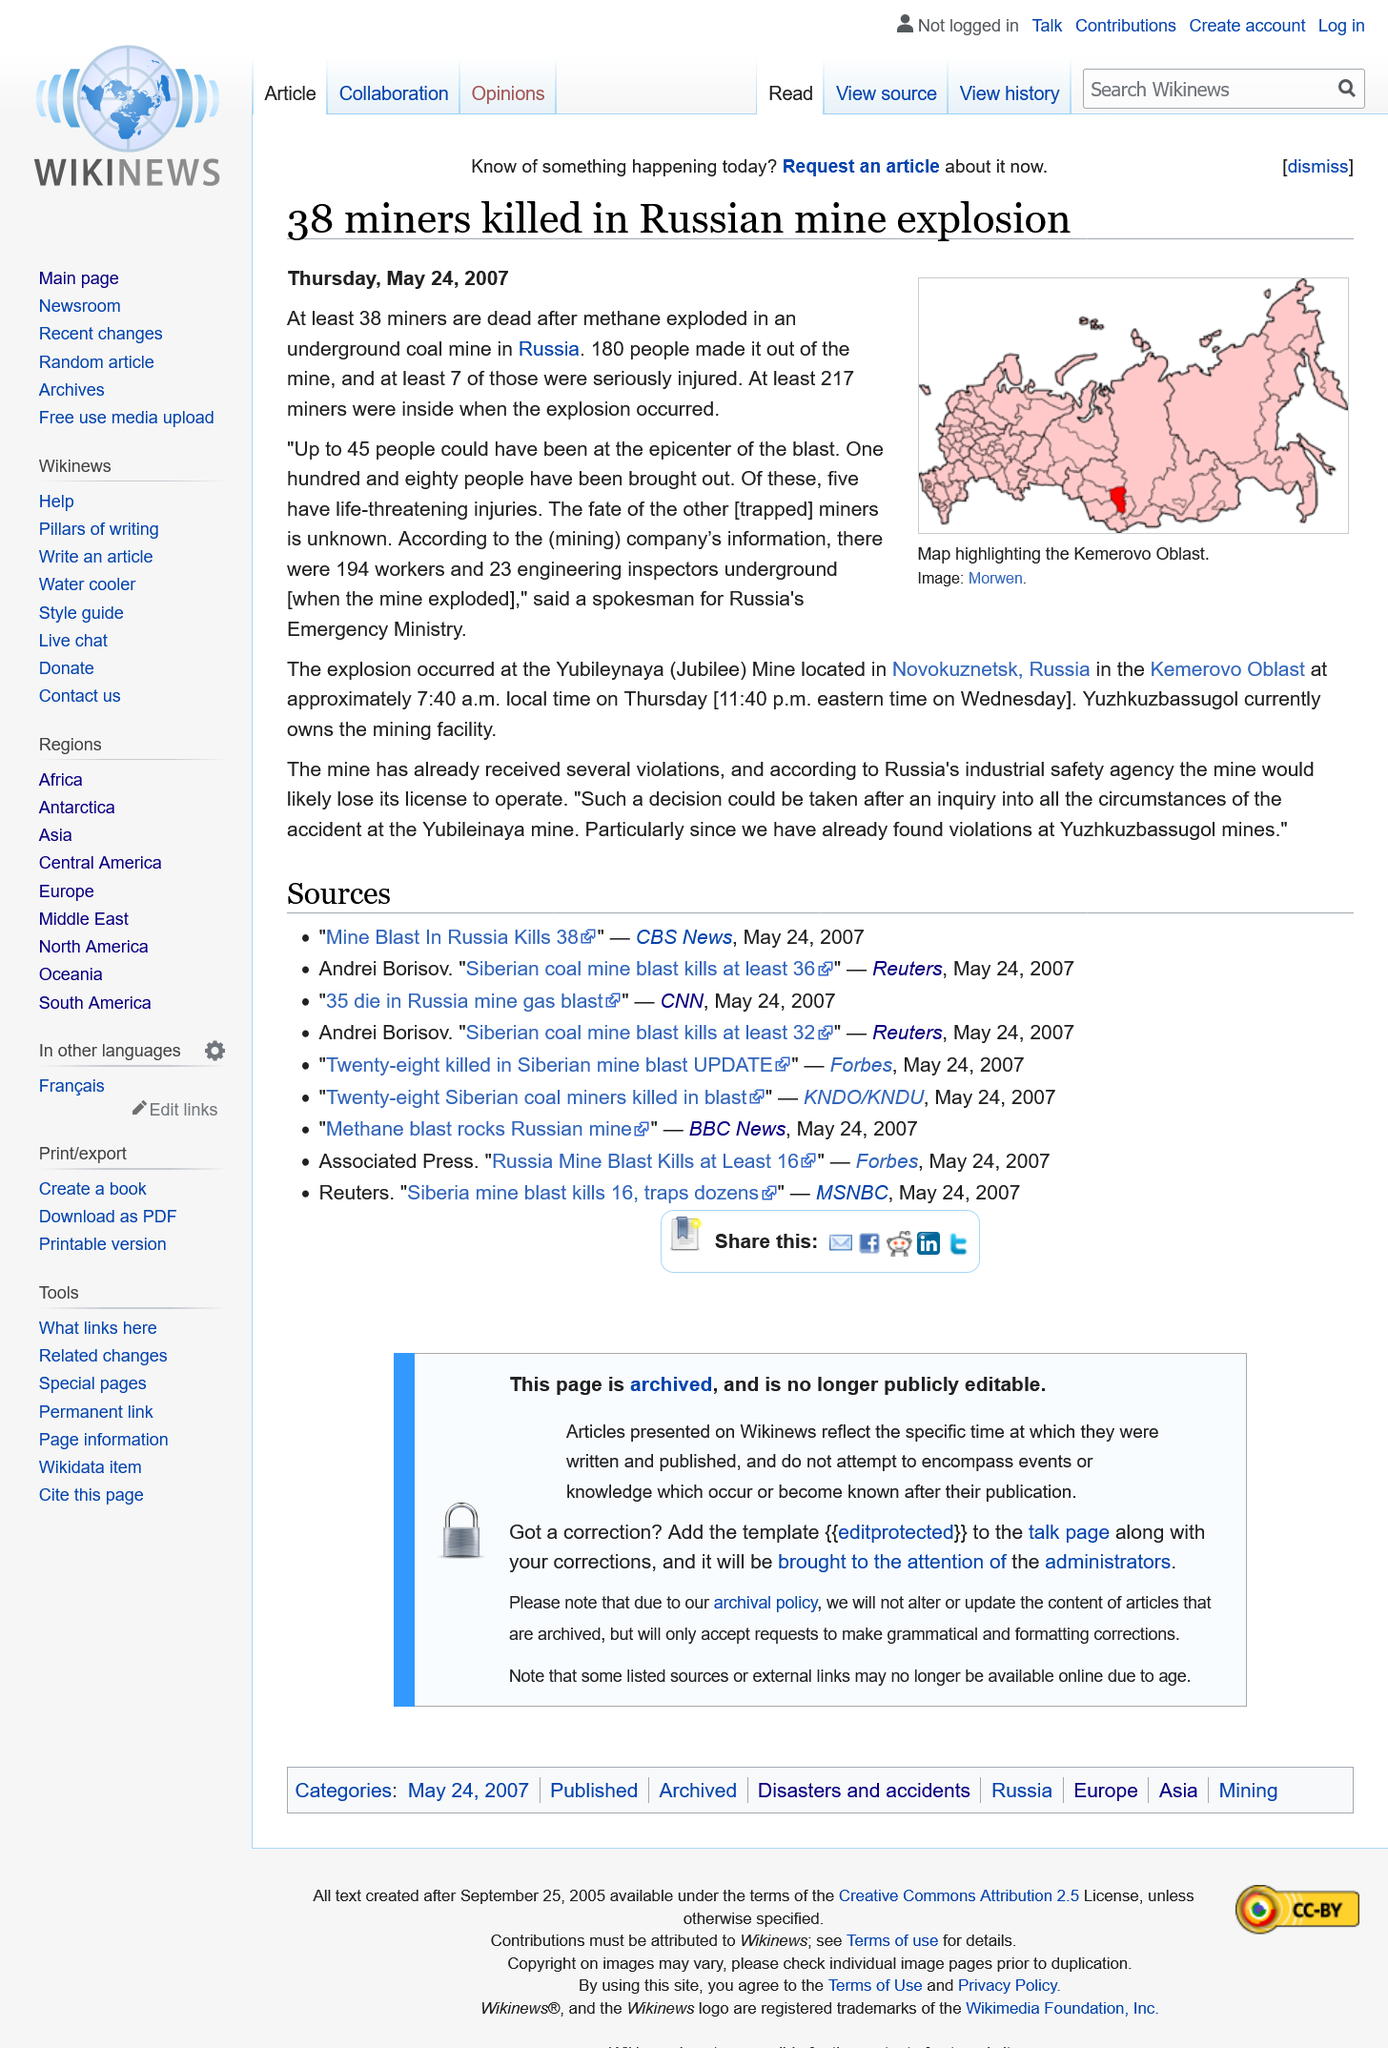Point out several critical features in this image. 38 miners were killed. The source name of the map is Morwen. The map is from this source. The mine explosion occurred in Russia. 